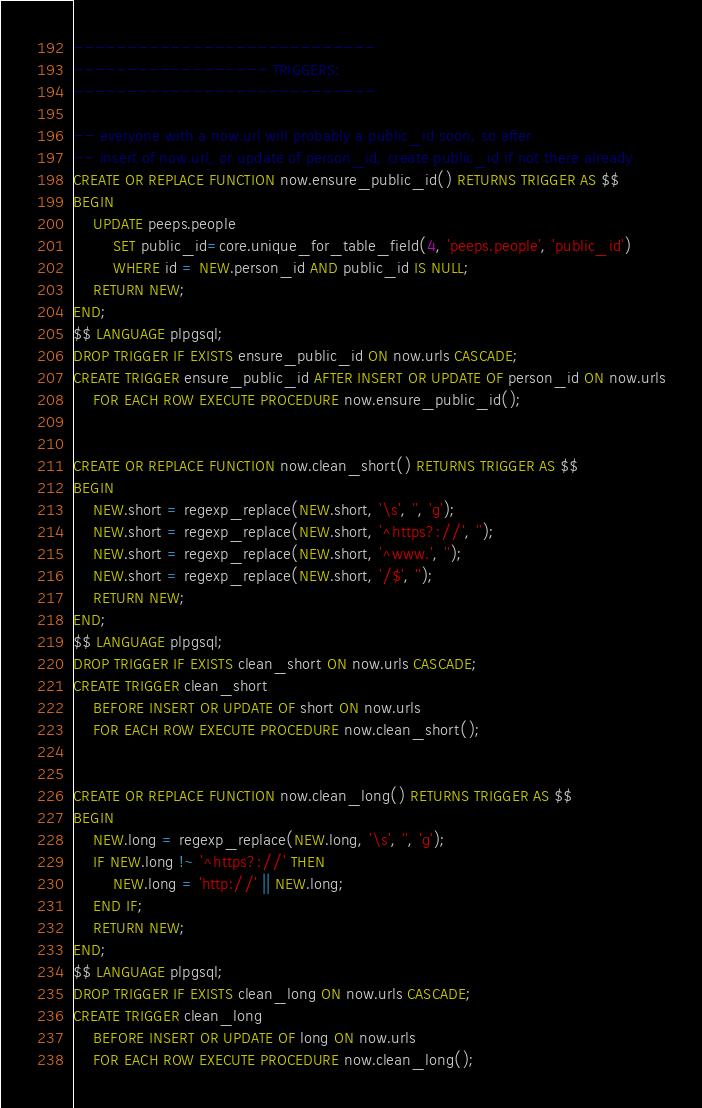<code> <loc_0><loc_0><loc_500><loc_500><_SQL_>----------------------------
------------------ TRIGGERS:
----------------------------

-- everyone with a now.url will probably a public_id soon, so after 
-- insert of now.url, or update of person_id, create public_id if not there already
CREATE OR REPLACE FUNCTION now.ensure_public_id() RETURNS TRIGGER AS $$
BEGIN
	UPDATE peeps.people
		SET public_id=core.unique_for_table_field(4, 'peeps.people', 'public_id')
		WHERE id = NEW.person_id AND public_id IS NULL;
	RETURN NEW;
END;
$$ LANGUAGE plpgsql;
DROP TRIGGER IF EXISTS ensure_public_id ON now.urls CASCADE;
CREATE TRIGGER ensure_public_id AFTER INSERT OR UPDATE OF person_id ON now.urls
	FOR EACH ROW EXECUTE PROCEDURE now.ensure_public_id();


CREATE OR REPLACE FUNCTION now.clean_short() RETURNS TRIGGER AS $$
BEGIN
	NEW.short = regexp_replace(NEW.short, '\s', '', 'g');
	NEW.short = regexp_replace(NEW.short, '^https?://', '');
	NEW.short = regexp_replace(NEW.short, '^www.', '');
	NEW.short = regexp_replace(NEW.short, '/$', '');
	RETURN NEW;
END;
$$ LANGUAGE plpgsql;
DROP TRIGGER IF EXISTS clean_short ON now.urls CASCADE;
CREATE TRIGGER clean_short
	BEFORE INSERT OR UPDATE OF short ON now.urls
	FOR EACH ROW EXECUTE PROCEDURE now.clean_short();


CREATE OR REPLACE FUNCTION now.clean_long() RETURNS TRIGGER AS $$
BEGIN
	NEW.long = regexp_replace(NEW.long, '\s', '', 'g');
	IF NEW.long !~ '^https?://' THEN
		NEW.long = 'http://' || NEW.long;
	END IF;
	RETURN NEW;
END;
$$ LANGUAGE plpgsql;
DROP TRIGGER IF EXISTS clean_long ON now.urls CASCADE;
CREATE TRIGGER clean_long
	BEFORE INSERT OR UPDATE OF long ON now.urls
	FOR EACH ROW EXECUTE PROCEDURE now.clean_long();

</code> 